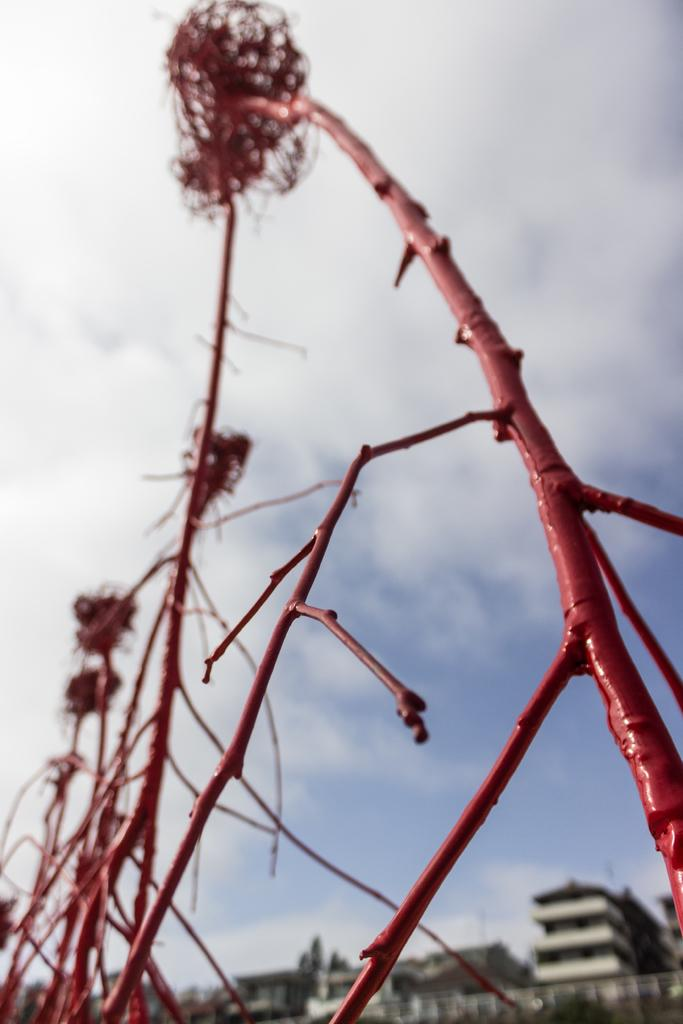What objects are located in the front of the image? There are plates in the front of the image. What type of structures can be seen in the background of the image? There are buildings in the background of the image. What is visible at the top of the image? The sky is visible at the top of the image. What can be observed in the sky? Clouds are present in the sky. Can you hear the flower crying in the image? There is no flower present in the image, and therefore no such sound can be heard. 